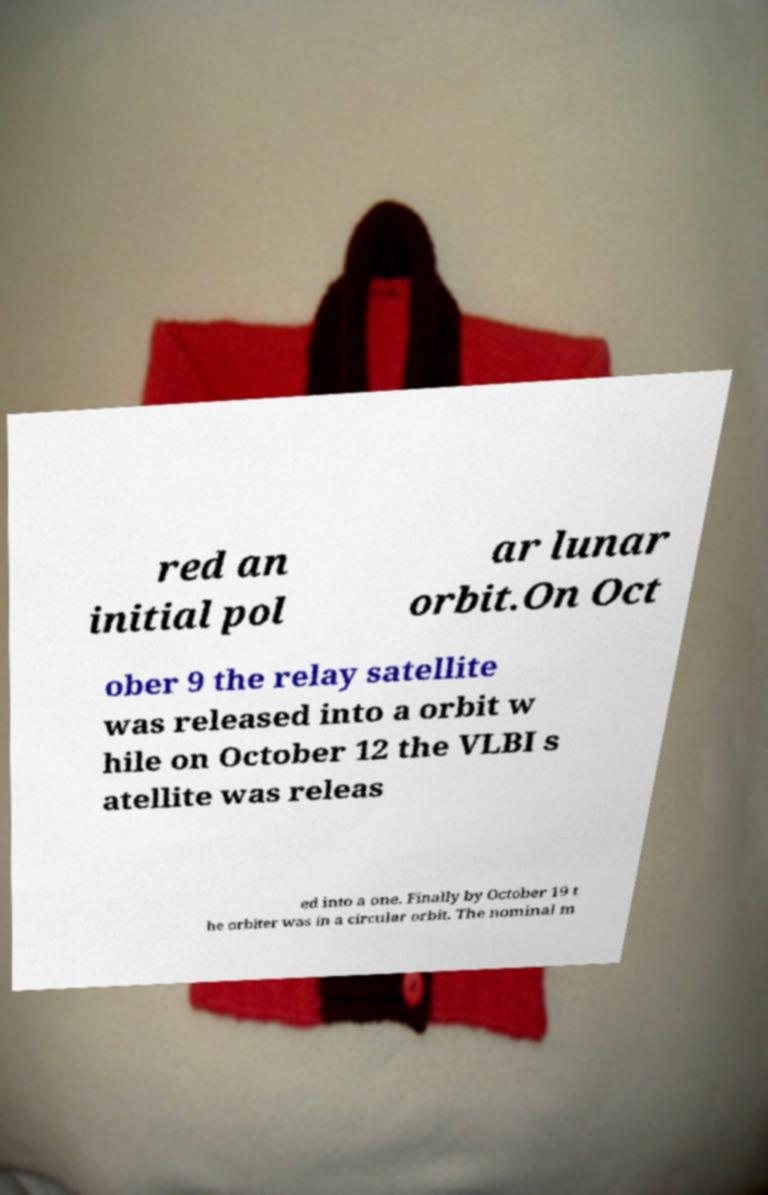What messages or text are displayed in this image? I need them in a readable, typed format. red an initial pol ar lunar orbit.On Oct ober 9 the relay satellite was released into a orbit w hile on October 12 the VLBI s atellite was releas ed into a one. Finally by October 19 t he orbiter was in a circular orbit. The nominal m 